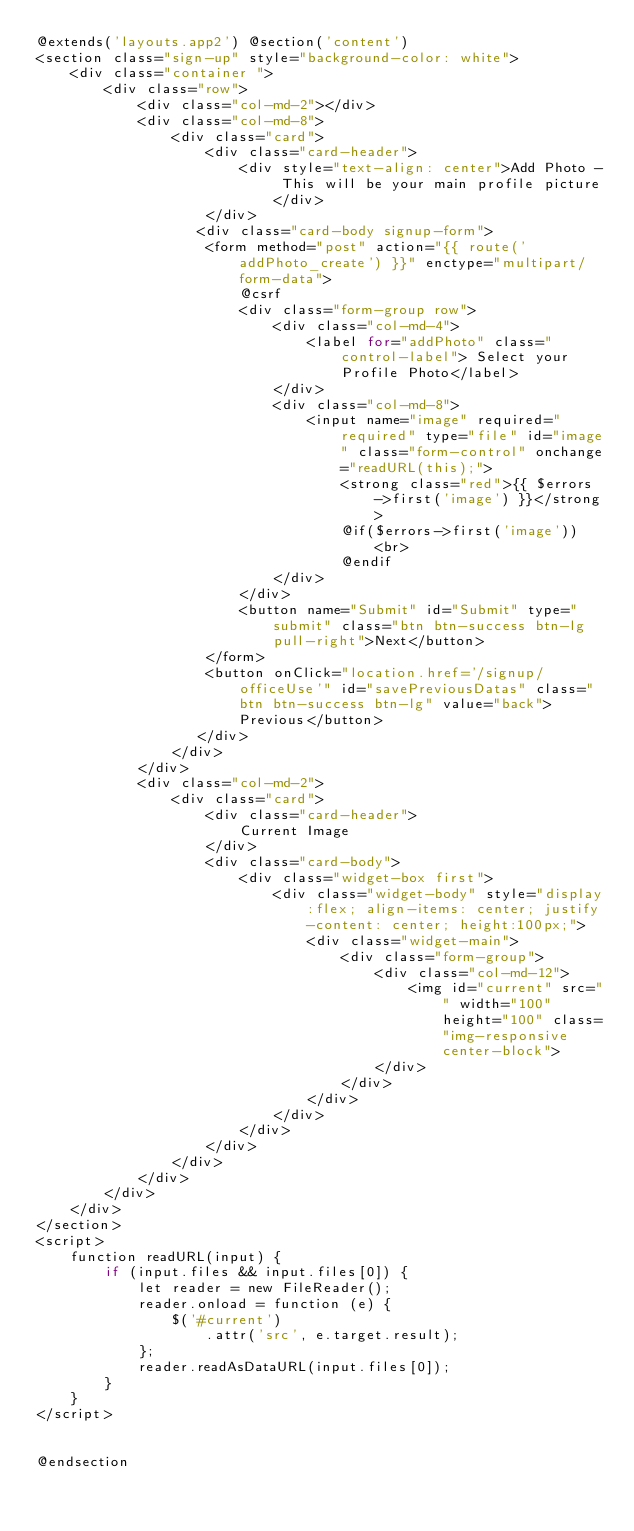Convert code to text. <code><loc_0><loc_0><loc_500><loc_500><_PHP_>@extends('layouts.app2') @section('content')
<section class="sign-up" style="background-color: white">
    <div class="container ">
        <div class="row">
            <div class="col-md-2"></div>
            <div class="col-md-8">
                <div class="card">
                    <div class="card-header">
                        <div style="text-align: center">Add Photo - This will be your main profile picture</div>
                    </div>
                   <div class="card-body signup-form">
                    <form method="post" action="{{ route('addPhoto_create') }}" enctype="multipart/form-data">
                        @csrf
                        <div class="form-group row">
                            <div class="col-md-4">
                                <label for="addPhoto" class="control-label"> Select your Profile Photo</label>
                            </div>
                            <div class="col-md-8">
                                <input name="image" required="required" type="file" id="image" class="form-control" onchange="readURL(this);">
                                    <strong class="red">{{ $errors->first('image') }}</strong>
                                    @if($errors->first('image'))
                                        <br>
                                    @endif
                            </div>
                        </div>
                        <button name="Submit" id="Submit" type="submit" class="btn btn-success btn-lg pull-right">Next</button>
                    </form>
                    <button onClick="location.href='/signup/officeUse'" id="savePreviousDatas" class="btn btn-success btn-lg" value="back">Previous</button>
                   </div>
                </div>
            </div>
            <div class="col-md-2">
                <div class="card">
                    <div class="card-header">
                        Current Image
                    </div>
                    <div class="card-body">
                        <div class="widget-box first">
                            <div class="widget-body" style="display:flex; align-items: center; justify-content: center; height:100px;">
                                <div class="widget-main">
                                    <div class="form-group">
                                        <div class="col-md-12">
                                            <img id="current" src="" width="100" height="100" class="img-responsive center-block">
                                        </div>
                                    </div>
                                </div>
                            </div>
                        </div>
                    </div>
                </div>
            </div>
        </div>
    </div>
</section>
<script>
    function readURL(input) {
        if (input.files && input.files[0]) {
            let reader = new FileReader();
            reader.onload = function (e) {
                $('#current')
                    .attr('src', e.target.result);
            };
            reader.readAsDataURL(input.files[0]);
        }
    }
</script>


@endsection
</code> 